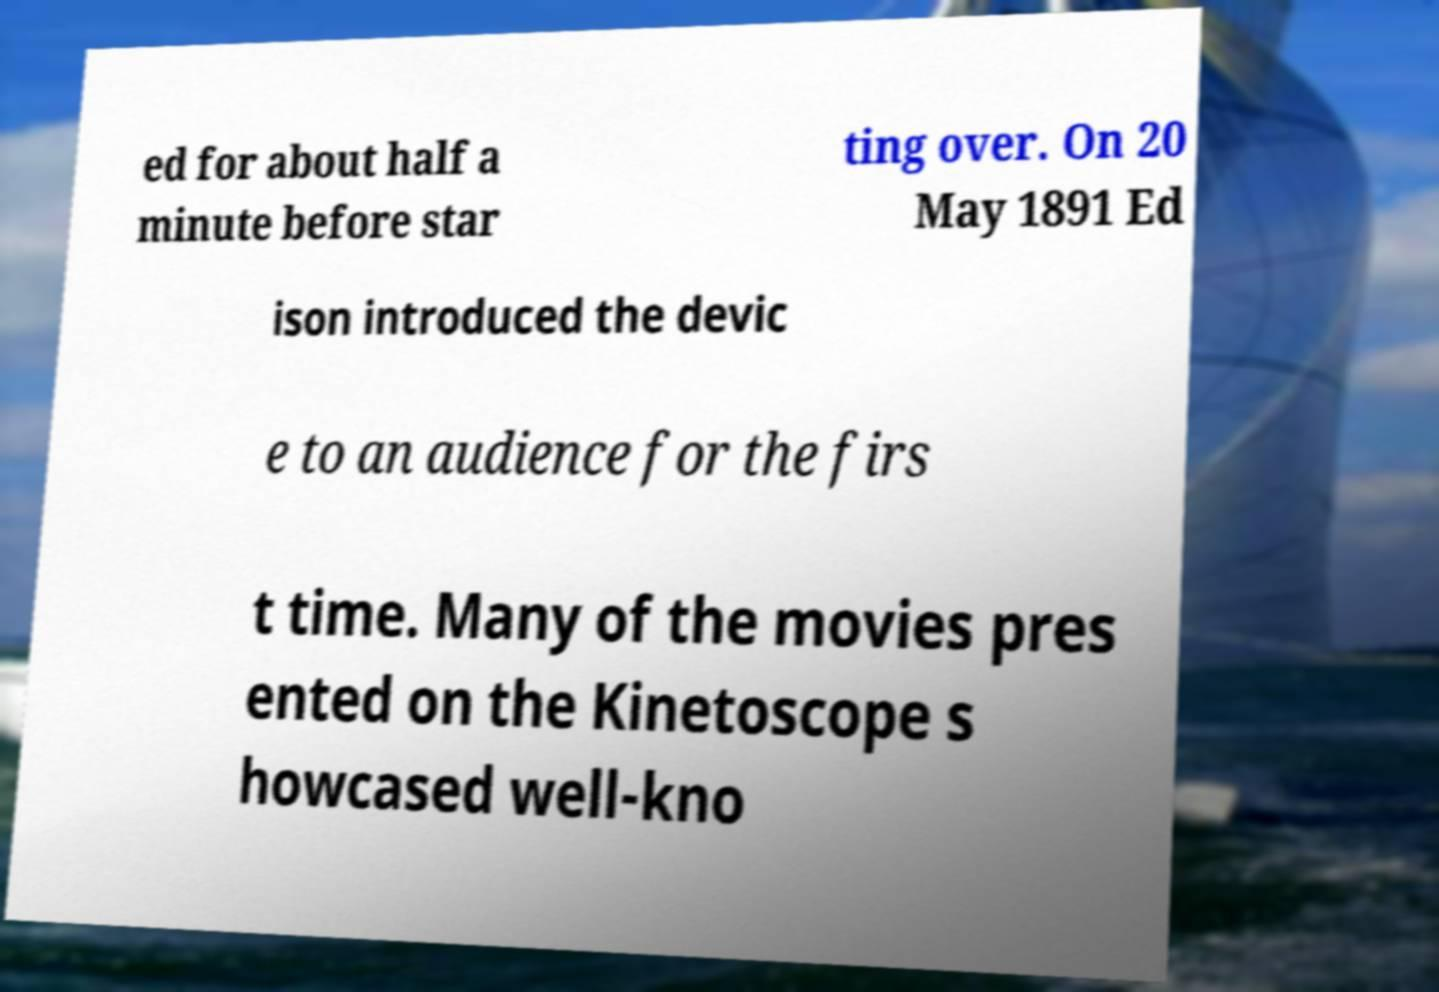Could you extract and type out the text from this image? ed for about half a minute before star ting over. On 20 May 1891 Ed ison introduced the devic e to an audience for the firs t time. Many of the movies pres ented on the Kinetoscope s howcased well-kno 